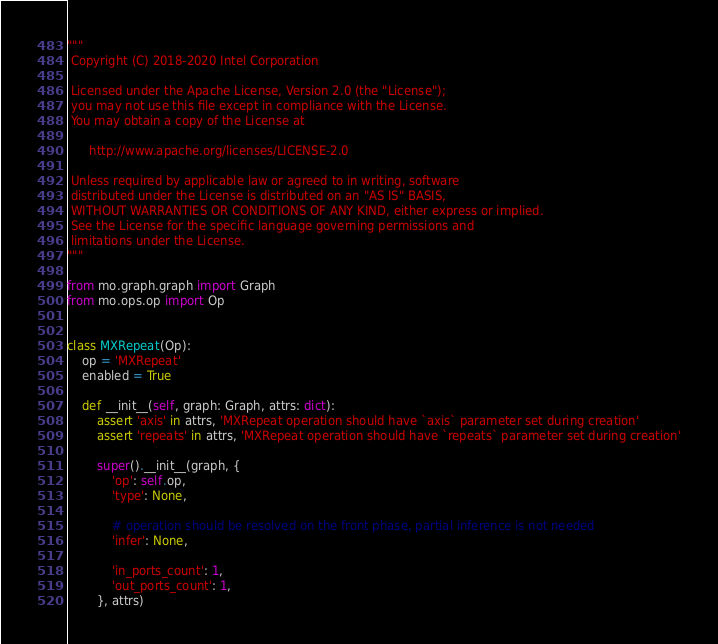Convert code to text. <code><loc_0><loc_0><loc_500><loc_500><_Python_>"""
 Copyright (C) 2018-2020 Intel Corporation

 Licensed under the Apache License, Version 2.0 (the "License");
 you may not use this file except in compliance with the License.
 You may obtain a copy of the License at

      http://www.apache.org/licenses/LICENSE-2.0

 Unless required by applicable law or agreed to in writing, software
 distributed under the License is distributed on an "AS IS" BASIS,
 WITHOUT WARRANTIES OR CONDITIONS OF ANY KIND, either express or implied.
 See the License for the specific language governing permissions and
 limitations under the License.
"""

from mo.graph.graph import Graph
from mo.ops.op import Op


class MXRepeat(Op):
    op = 'MXRepeat'
    enabled = True

    def __init__(self, graph: Graph, attrs: dict):
        assert 'axis' in attrs, 'MXRepeat operation should have `axis` parameter set during creation'
        assert 'repeats' in attrs, 'MXRepeat operation should have `repeats` parameter set during creation'

        super().__init__(graph, {
            'op': self.op,
            'type': None,

            # operation should be resolved on the front phase, partial inference is not needed
            'infer': None,

            'in_ports_count': 1,
            'out_ports_count': 1,
        }, attrs)
</code> 